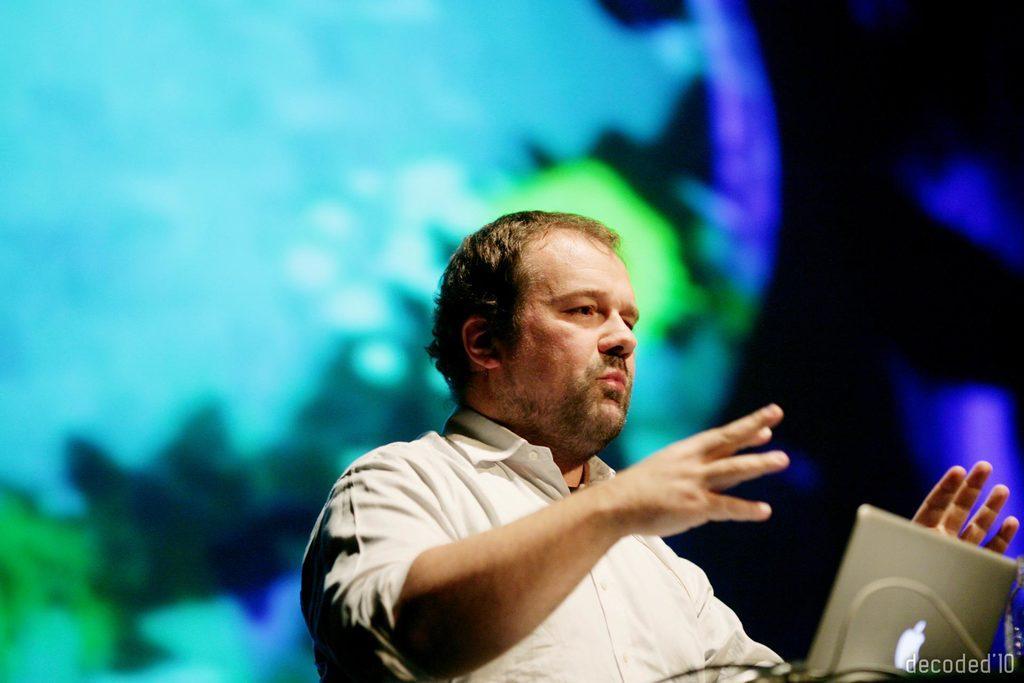Please provide a concise description of this image. In this picture we can observe a man standing in front of a laptop. He is wearing a white color shirt. In the background we can observe blue, green and black colors. 